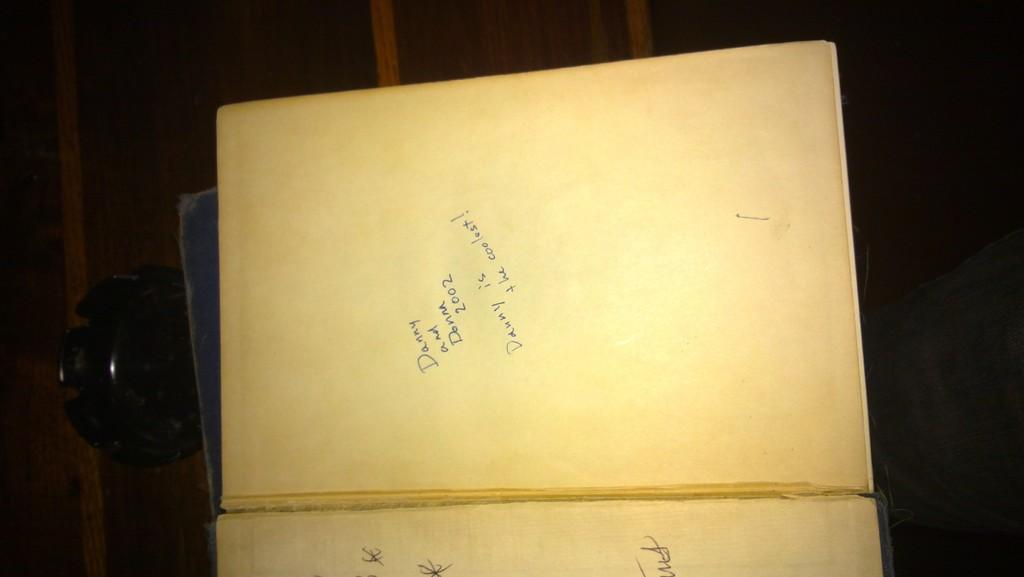<image>
Create a compact narrative representing the image presented. an open book with the words 'danny and donna 2002' written on it 